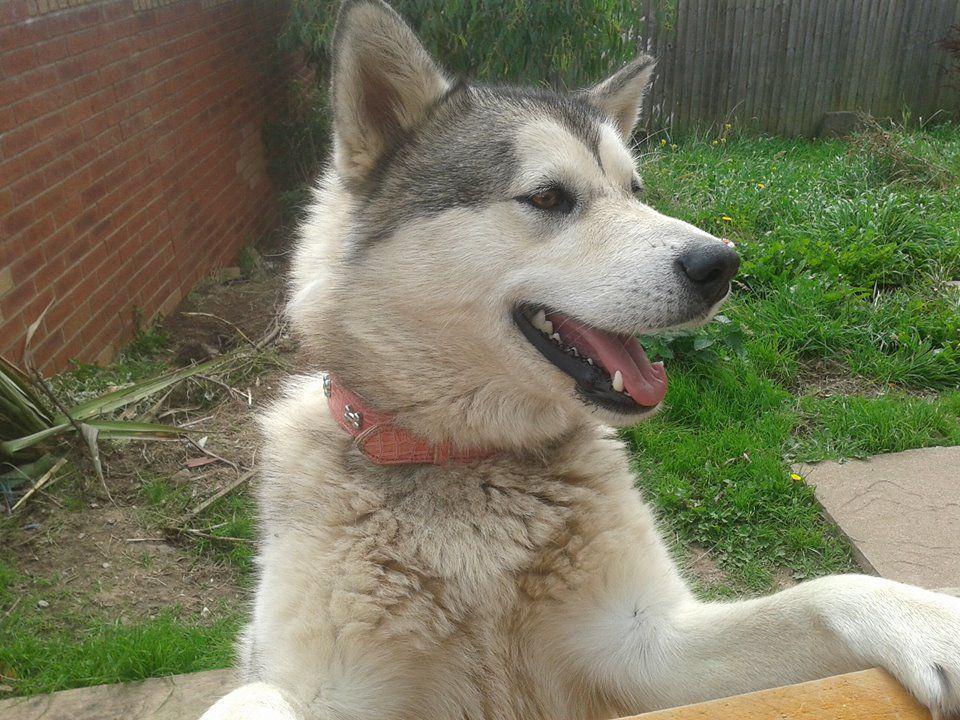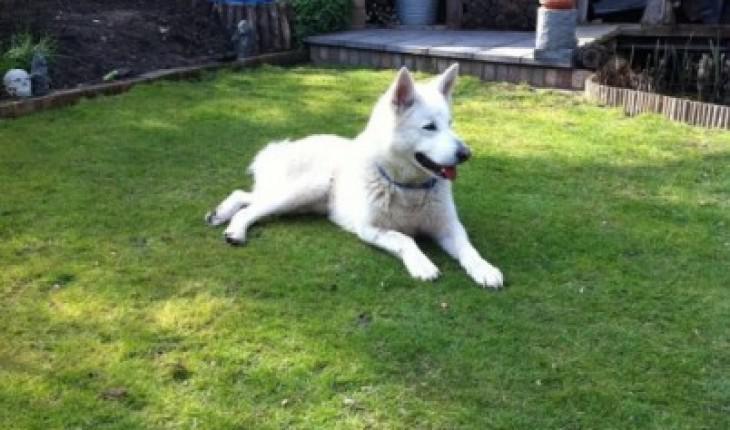The first image is the image on the left, the second image is the image on the right. Given the left and right images, does the statement "One image shows a dog sitting upright, and the other image features a dog standing on all fours." hold true? Answer yes or no. No. The first image is the image on the left, the second image is the image on the right. Evaluate the accuracy of this statement regarding the images: "At least one dog is on a leash.". Is it true? Answer yes or no. No. 